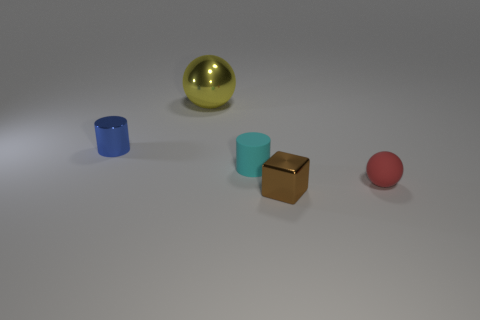Add 1 tiny brown matte blocks. How many objects exist? 6 Subtract all cylinders. How many objects are left? 3 Add 3 shiny things. How many shiny things are left? 6 Add 2 tiny red matte objects. How many tiny red matte objects exist? 3 Subtract 0 red blocks. How many objects are left? 5 Subtract all cyan spheres. Subtract all gray cubes. How many spheres are left? 2 Subtract all big yellow things. Subtract all red rubber objects. How many objects are left? 3 